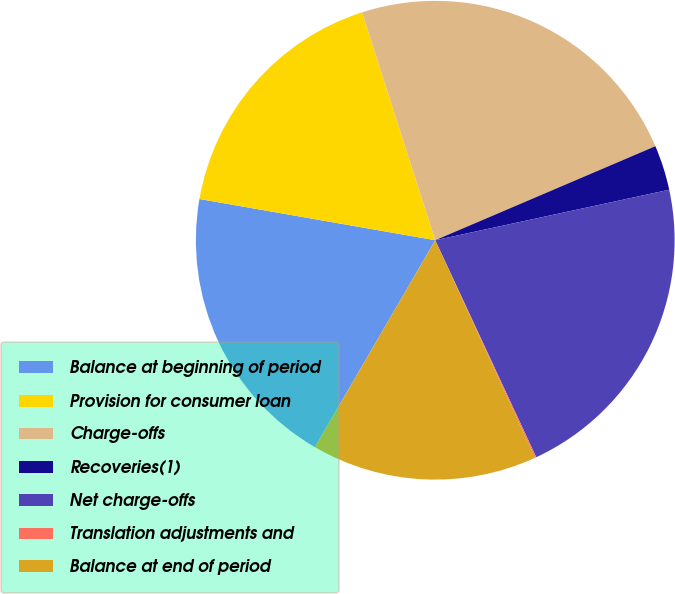<chart> <loc_0><loc_0><loc_500><loc_500><pie_chart><fcel>Balance at beginning of period<fcel>Provision for consumer loan<fcel>Charge-offs<fcel>Recoveries(1)<fcel>Net charge-offs<fcel>Translation adjustments and<fcel>Balance at end of period<nl><fcel>19.37%<fcel>17.3%<fcel>23.52%<fcel>3.04%<fcel>21.45%<fcel>0.09%<fcel>15.23%<nl></chart> 